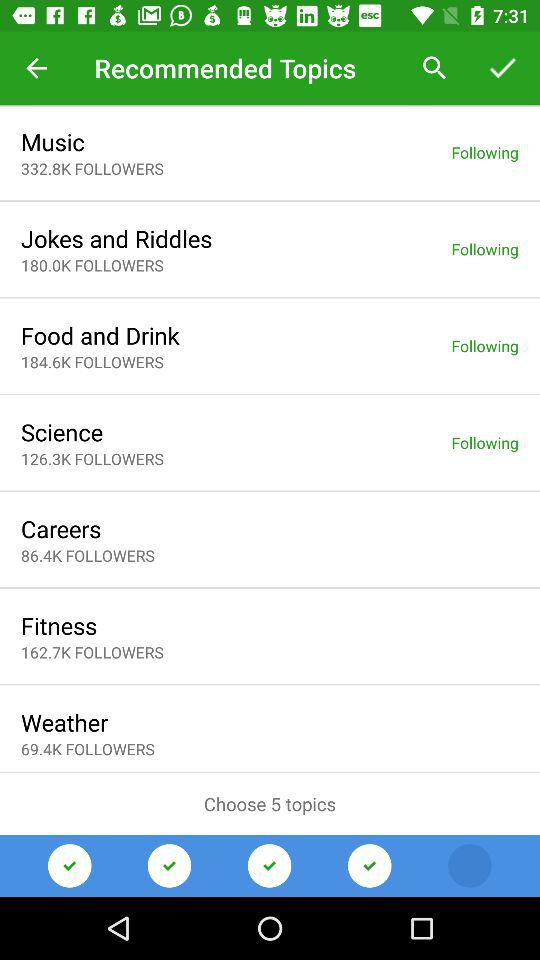What is the total number of followers of "Food and Drink"? The total number of followers is 184.6K. 